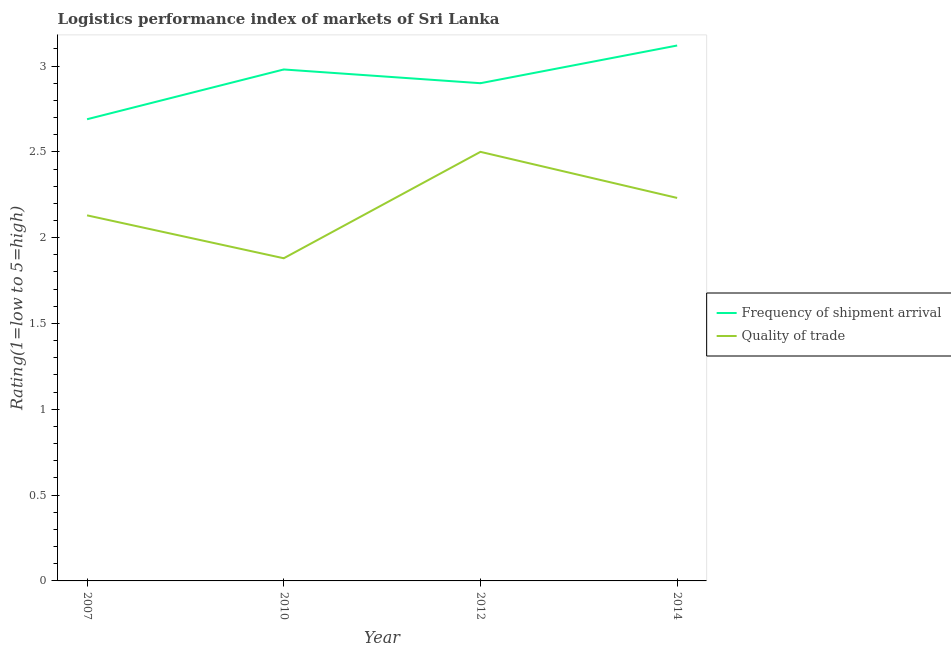What is the lpi of frequency of shipment arrival in 2010?
Your answer should be very brief. 2.98. Across all years, what is the maximum lpi of frequency of shipment arrival?
Offer a very short reply. 3.12. Across all years, what is the minimum lpi quality of trade?
Provide a succinct answer. 1.88. In which year was the lpi quality of trade minimum?
Provide a short and direct response. 2010. What is the total lpi quality of trade in the graph?
Your response must be concise. 8.74. What is the difference between the lpi quality of trade in 2012 and that in 2014?
Your answer should be very brief. 0.27. What is the difference between the lpi quality of trade in 2007 and the lpi of frequency of shipment arrival in 2010?
Your answer should be very brief. -0.85. What is the average lpi of frequency of shipment arrival per year?
Give a very brief answer. 2.92. In the year 2014, what is the difference between the lpi of frequency of shipment arrival and lpi quality of trade?
Your answer should be very brief. 0.89. What is the ratio of the lpi quality of trade in 2007 to that in 2014?
Give a very brief answer. 0.95. What is the difference between the highest and the second highest lpi quality of trade?
Your answer should be compact. 0.27. What is the difference between the highest and the lowest lpi quality of trade?
Keep it short and to the point. 0.62. In how many years, is the lpi quality of trade greater than the average lpi quality of trade taken over all years?
Your answer should be compact. 2. Is the sum of the lpi quality of trade in 2012 and 2014 greater than the maximum lpi of frequency of shipment arrival across all years?
Offer a very short reply. Yes. How many years are there in the graph?
Provide a succinct answer. 4. What is the difference between two consecutive major ticks on the Y-axis?
Offer a very short reply. 0.5. Are the values on the major ticks of Y-axis written in scientific E-notation?
Offer a terse response. No. Does the graph contain grids?
Make the answer very short. No. How many legend labels are there?
Provide a short and direct response. 2. What is the title of the graph?
Your response must be concise. Logistics performance index of markets of Sri Lanka. What is the label or title of the Y-axis?
Provide a short and direct response. Rating(1=low to 5=high). What is the Rating(1=low to 5=high) of Frequency of shipment arrival in 2007?
Your answer should be very brief. 2.69. What is the Rating(1=low to 5=high) of Quality of trade in 2007?
Provide a succinct answer. 2.13. What is the Rating(1=low to 5=high) in Frequency of shipment arrival in 2010?
Your response must be concise. 2.98. What is the Rating(1=low to 5=high) of Quality of trade in 2010?
Provide a short and direct response. 1.88. What is the Rating(1=low to 5=high) of Quality of trade in 2012?
Make the answer very short. 2.5. What is the Rating(1=low to 5=high) of Frequency of shipment arrival in 2014?
Your answer should be very brief. 3.12. What is the Rating(1=low to 5=high) of Quality of trade in 2014?
Ensure brevity in your answer.  2.23. Across all years, what is the maximum Rating(1=low to 5=high) of Frequency of shipment arrival?
Your answer should be compact. 3.12. Across all years, what is the maximum Rating(1=low to 5=high) of Quality of trade?
Your answer should be compact. 2.5. Across all years, what is the minimum Rating(1=low to 5=high) in Frequency of shipment arrival?
Give a very brief answer. 2.69. Across all years, what is the minimum Rating(1=low to 5=high) in Quality of trade?
Provide a succinct answer. 1.88. What is the total Rating(1=low to 5=high) of Frequency of shipment arrival in the graph?
Offer a terse response. 11.69. What is the total Rating(1=low to 5=high) of Quality of trade in the graph?
Ensure brevity in your answer.  8.74. What is the difference between the Rating(1=low to 5=high) of Frequency of shipment arrival in 2007 and that in 2010?
Your answer should be compact. -0.29. What is the difference between the Rating(1=low to 5=high) of Frequency of shipment arrival in 2007 and that in 2012?
Your answer should be compact. -0.21. What is the difference between the Rating(1=low to 5=high) of Quality of trade in 2007 and that in 2012?
Make the answer very short. -0.37. What is the difference between the Rating(1=low to 5=high) in Frequency of shipment arrival in 2007 and that in 2014?
Give a very brief answer. -0.43. What is the difference between the Rating(1=low to 5=high) in Quality of trade in 2007 and that in 2014?
Provide a succinct answer. -0.1. What is the difference between the Rating(1=low to 5=high) in Frequency of shipment arrival in 2010 and that in 2012?
Your answer should be very brief. 0.08. What is the difference between the Rating(1=low to 5=high) in Quality of trade in 2010 and that in 2012?
Keep it short and to the point. -0.62. What is the difference between the Rating(1=low to 5=high) in Frequency of shipment arrival in 2010 and that in 2014?
Give a very brief answer. -0.14. What is the difference between the Rating(1=low to 5=high) in Quality of trade in 2010 and that in 2014?
Your answer should be compact. -0.35. What is the difference between the Rating(1=low to 5=high) in Frequency of shipment arrival in 2012 and that in 2014?
Give a very brief answer. -0.22. What is the difference between the Rating(1=low to 5=high) of Quality of trade in 2012 and that in 2014?
Your answer should be very brief. 0.27. What is the difference between the Rating(1=low to 5=high) of Frequency of shipment arrival in 2007 and the Rating(1=low to 5=high) of Quality of trade in 2010?
Make the answer very short. 0.81. What is the difference between the Rating(1=low to 5=high) in Frequency of shipment arrival in 2007 and the Rating(1=low to 5=high) in Quality of trade in 2012?
Offer a very short reply. 0.19. What is the difference between the Rating(1=low to 5=high) of Frequency of shipment arrival in 2007 and the Rating(1=low to 5=high) of Quality of trade in 2014?
Give a very brief answer. 0.46. What is the difference between the Rating(1=low to 5=high) of Frequency of shipment arrival in 2010 and the Rating(1=low to 5=high) of Quality of trade in 2012?
Offer a very short reply. 0.48. What is the difference between the Rating(1=low to 5=high) of Frequency of shipment arrival in 2010 and the Rating(1=low to 5=high) of Quality of trade in 2014?
Provide a succinct answer. 0.75. What is the difference between the Rating(1=low to 5=high) of Frequency of shipment arrival in 2012 and the Rating(1=low to 5=high) of Quality of trade in 2014?
Offer a terse response. 0.67. What is the average Rating(1=low to 5=high) of Frequency of shipment arrival per year?
Ensure brevity in your answer.  2.92. What is the average Rating(1=low to 5=high) in Quality of trade per year?
Offer a terse response. 2.19. In the year 2007, what is the difference between the Rating(1=low to 5=high) of Frequency of shipment arrival and Rating(1=low to 5=high) of Quality of trade?
Your answer should be very brief. 0.56. In the year 2010, what is the difference between the Rating(1=low to 5=high) in Frequency of shipment arrival and Rating(1=low to 5=high) in Quality of trade?
Keep it short and to the point. 1.1. In the year 2014, what is the difference between the Rating(1=low to 5=high) in Frequency of shipment arrival and Rating(1=low to 5=high) in Quality of trade?
Your answer should be very brief. 0.89. What is the ratio of the Rating(1=low to 5=high) in Frequency of shipment arrival in 2007 to that in 2010?
Offer a very short reply. 0.9. What is the ratio of the Rating(1=low to 5=high) in Quality of trade in 2007 to that in 2010?
Provide a short and direct response. 1.13. What is the ratio of the Rating(1=low to 5=high) of Frequency of shipment arrival in 2007 to that in 2012?
Give a very brief answer. 0.93. What is the ratio of the Rating(1=low to 5=high) of Quality of trade in 2007 to that in 2012?
Offer a terse response. 0.85. What is the ratio of the Rating(1=low to 5=high) of Frequency of shipment arrival in 2007 to that in 2014?
Your response must be concise. 0.86. What is the ratio of the Rating(1=low to 5=high) in Quality of trade in 2007 to that in 2014?
Your answer should be compact. 0.95. What is the ratio of the Rating(1=low to 5=high) of Frequency of shipment arrival in 2010 to that in 2012?
Your response must be concise. 1.03. What is the ratio of the Rating(1=low to 5=high) of Quality of trade in 2010 to that in 2012?
Offer a terse response. 0.75. What is the ratio of the Rating(1=low to 5=high) of Frequency of shipment arrival in 2010 to that in 2014?
Keep it short and to the point. 0.96. What is the ratio of the Rating(1=low to 5=high) in Quality of trade in 2010 to that in 2014?
Keep it short and to the point. 0.84. What is the ratio of the Rating(1=low to 5=high) in Frequency of shipment arrival in 2012 to that in 2014?
Your answer should be very brief. 0.93. What is the ratio of the Rating(1=low to 5=high) of Quality of trade in 2012 to that in 2014?
Keep it short and to the point. 1.12. What is the difference between the highest and the second highest Rating(1=low to 5=high) of Frequency of shipment arrival?
Offer a terse response. 0.14. What is the difference between the highest and the second highest Rating(1=low to 5=high) in Quality of trade?
Offer a very short reply. 0.27. What is the difference between the highest and the lowest Rating(1=low to 5=high) of Frequency of shipment arrival?
Keep it short and to the point. 0.43. What is the difference between the highest and the lowest Rating(1=low to 5=high) of Quality of trade?
Offer a terse response. 0.62. 